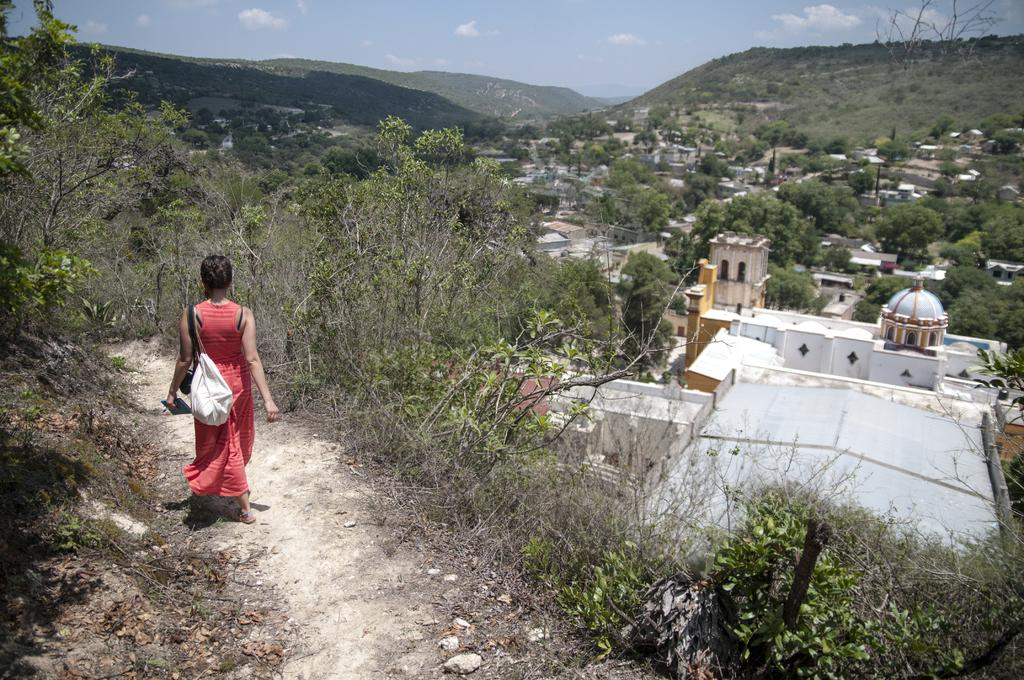What is the person in the image doing? There is a person walking in the image. What is the person carrying while walking? The person is wearing a white handbag. What can be seen on the right side of the image? There are trees and buildings on the right side of the image. What is visible in the background of the image? There are hills visible in the background of the image. What type of yam is being grown in the patch visible in the image? There is no patch or yam visible in the image; it features a person walking with a white handbag, surrounded by trees, buildings, and hills. 